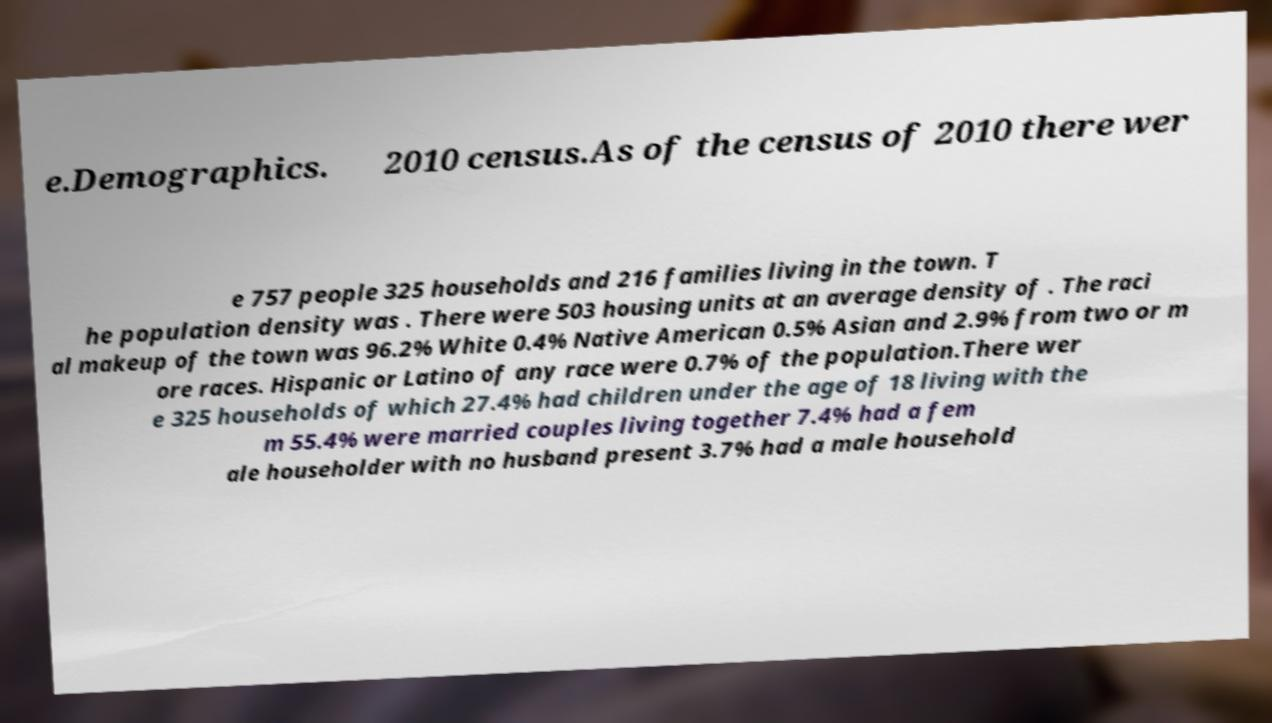What messages or text are displayed in this image? I need them in a readable, typed format. e.Demographics. 2010 census.As of the census of 2010 there wer e 757 people 325 households and 216 families living in the town. T he population density was . There were 503 housing units at an average density of . The raci al makeup of the town was 96.2% White 0.4% Native American 0.5% Asian and 2.9% from two or m ore races. Hispanic or Latino of any race were 0.7% of the population.There wer e 325 households of which 27.4% had children under the age of 18 living with the m 55.4% were married couples living together 7.4% had a fem ale householder with no husband present 3.7% had a male household 